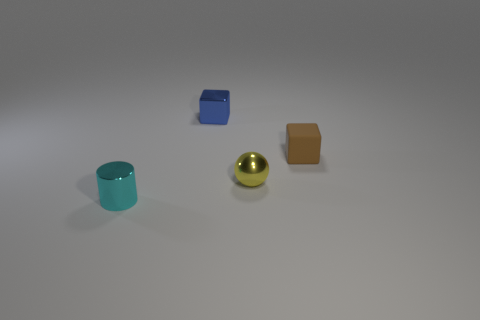What number of things are small blue things or purple shiny balls?
Keep it short and to the point. 1. There is a block that is to the left of the small metallic sphere that is on the right side of the metallic block; what is its size?
Keep it short and to the point. Small. How big is the brown thing?
Offer a very short reply. Small. The object that is on the left side of the rubber cube and right of the small blue metallic object has what shape?
Make the answer very short. Sphere. What is the color of the other tiny thing that is the same shape as the tiny blue shiny object?
Ensure brevity in your answer.  Brown. What number of things are metallic objects in front of the yellow object or shiny objects left of the tiny shiny block?
Keep it short and to the point. 1. What is the shape of the brown matte object?
Ensure brevity in your answer.  Cube. What number of big yellow blocks are made of the same material as the sphere?
Give a very brief answer. 0. What color is the shiny block?
Your answer should be compact. Blue. There is a metallic cylinder that is the same size as the matte cube; what color is it?
Keep it short and to the point. Cyan. 